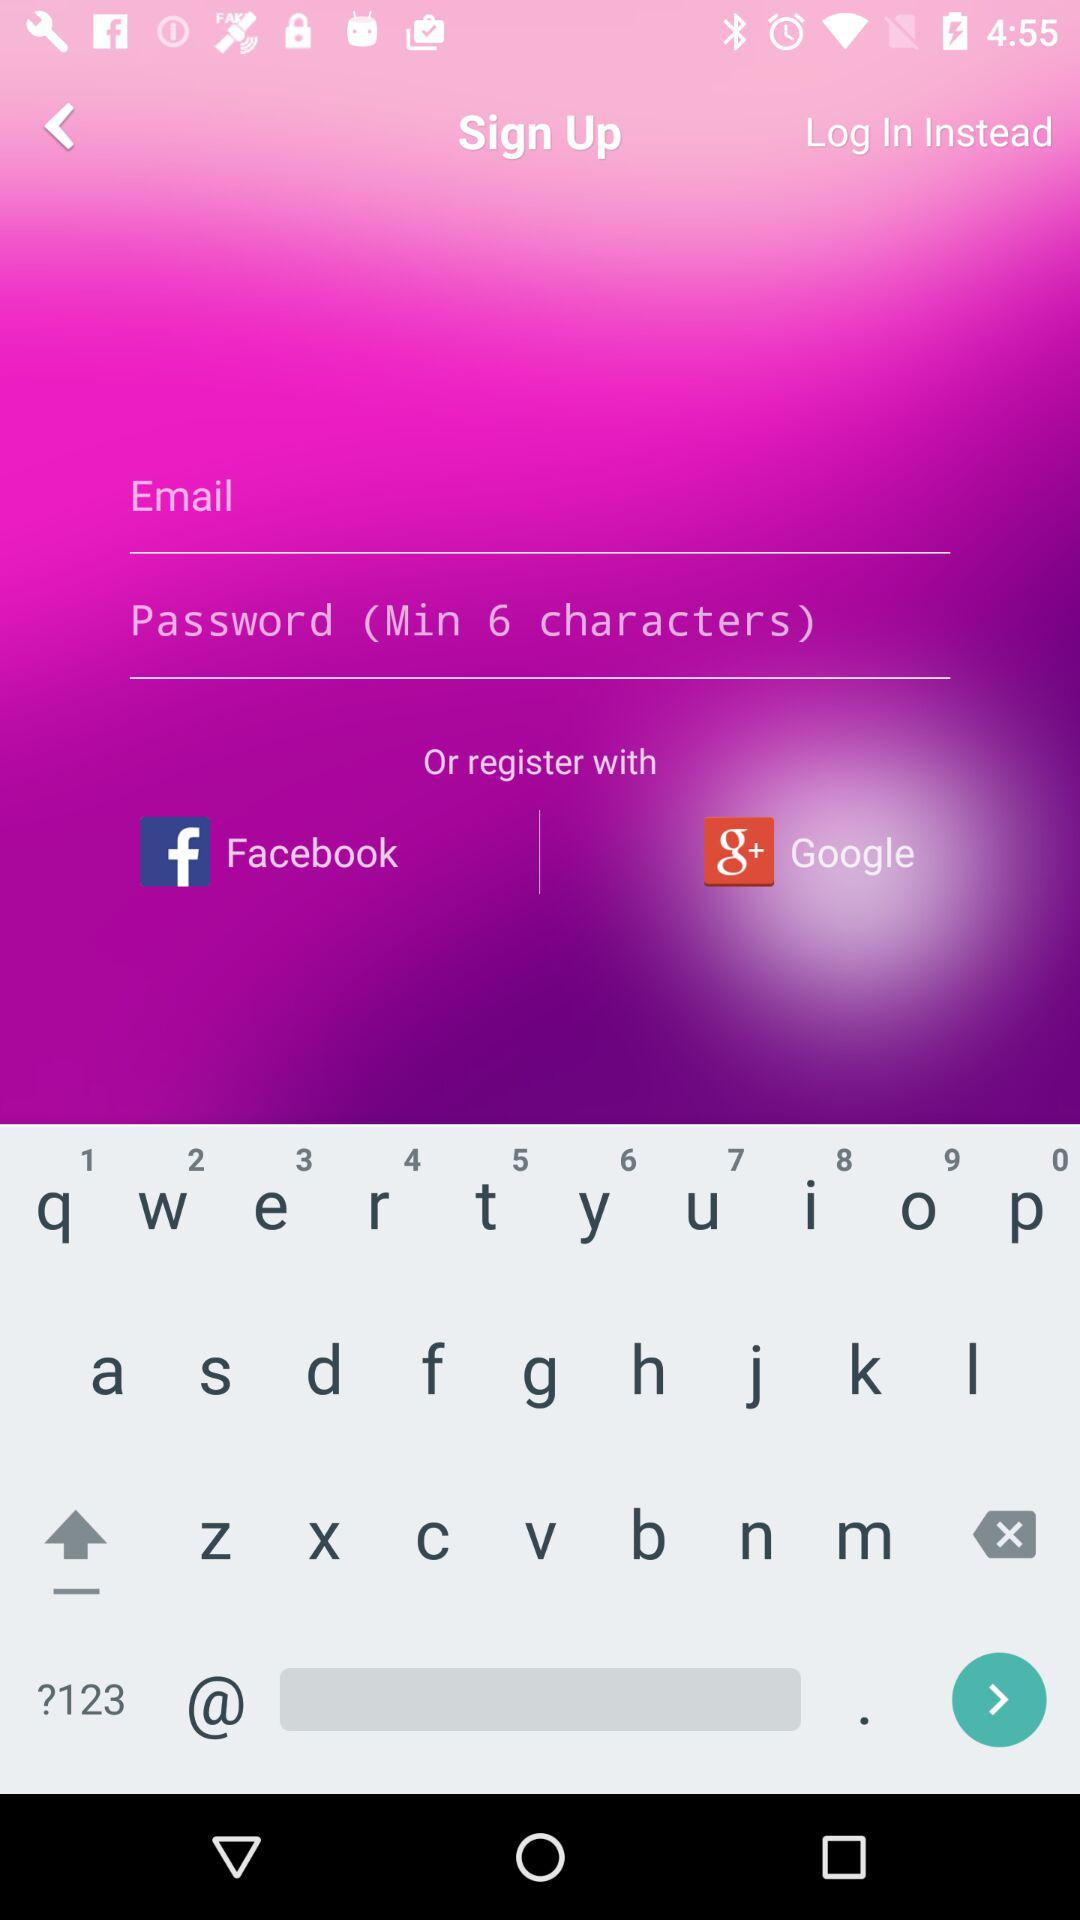What should be the length of the password? The length of the password should be "Min 6 characters". 